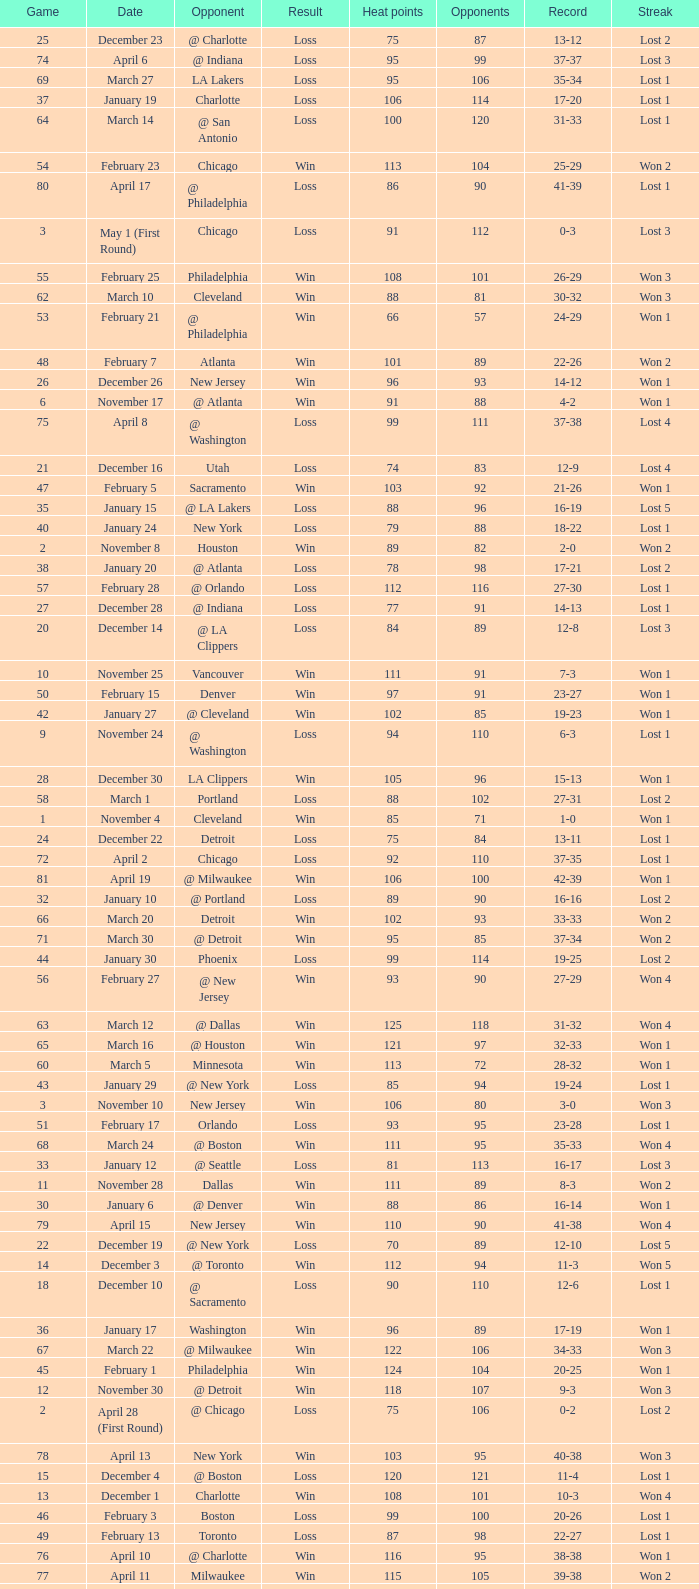What is Streak, when Heat Points is "101", and when Game is "16"? Lost 2. 